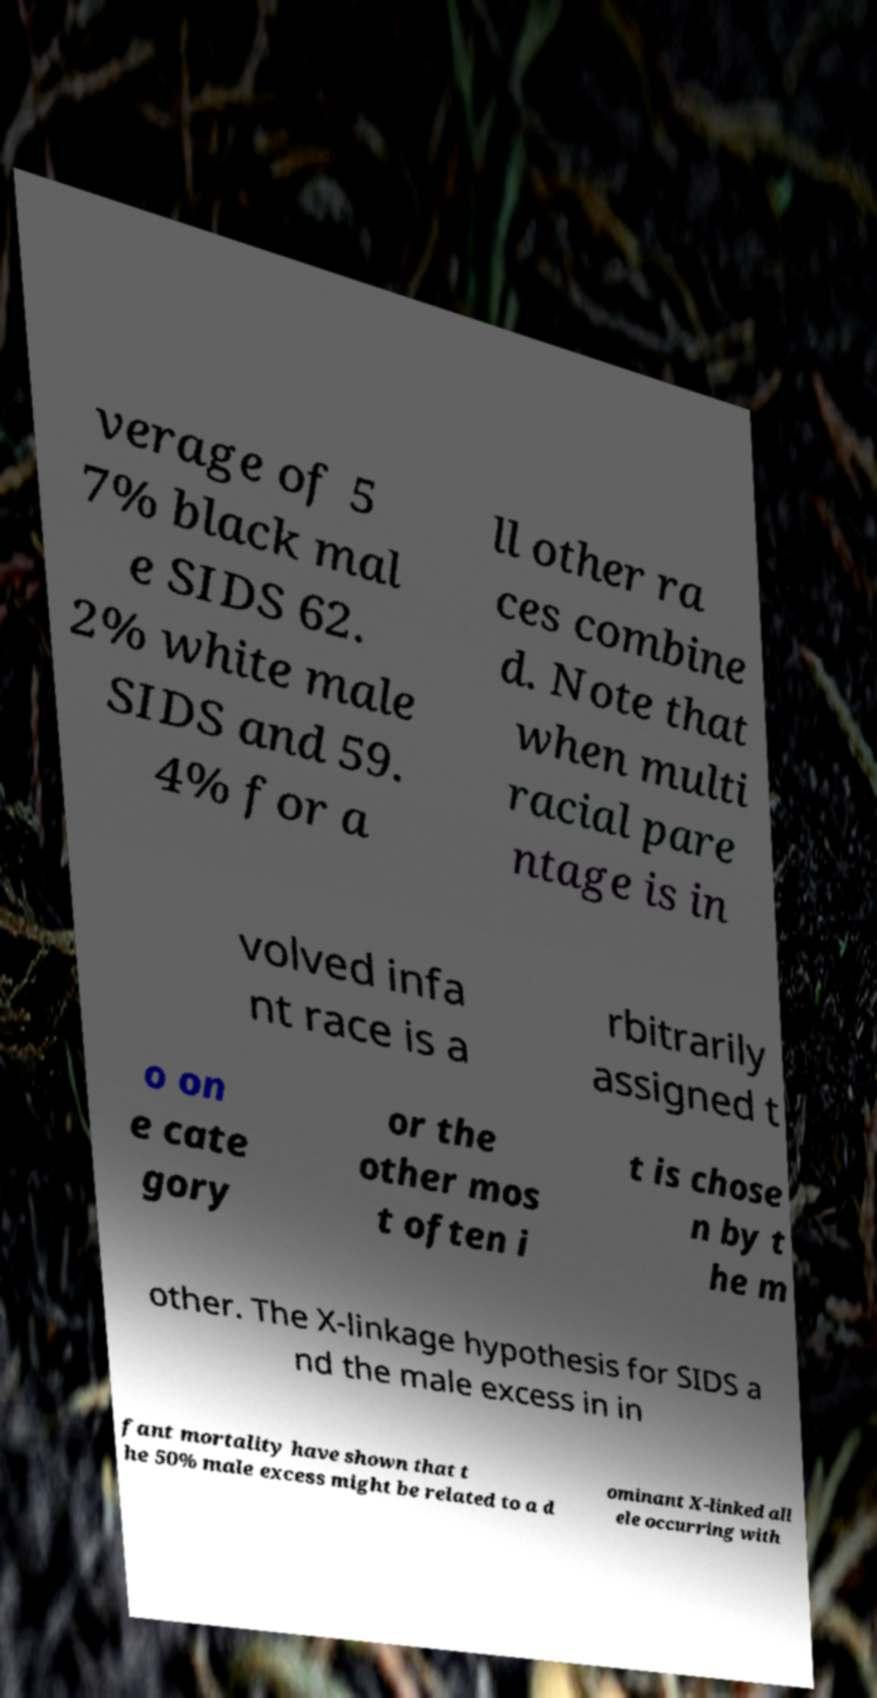There's text embedded in this image that I need extracted. Can you transcribe it verbatim? verage of 5 7% black mal e SIDS 62. 2% white male SIDS and 59. 4% for a ll other ra ces combine d. Note that when multi racial pare ntage is in volved infa nt race is a rbitrarily assigned t o on e cate gory or the other mos t often i t is chose n by t he m other. The X-linkage hypothesis for SIDS a nd the male excess in in fant mortality have shown that t he 50% male excess might be related to a d ominant X-linked all ele occurring with 